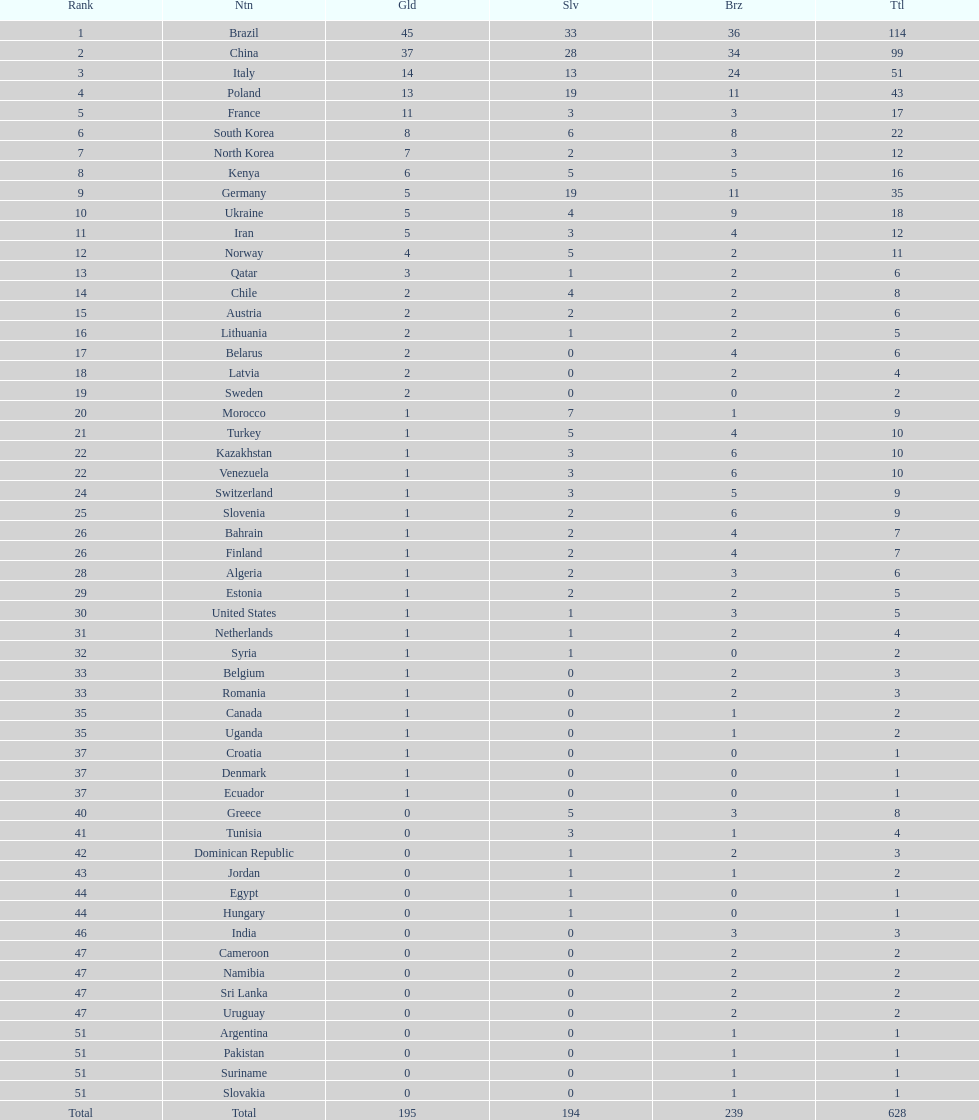South korea has how many more medals that north korea? 10. 